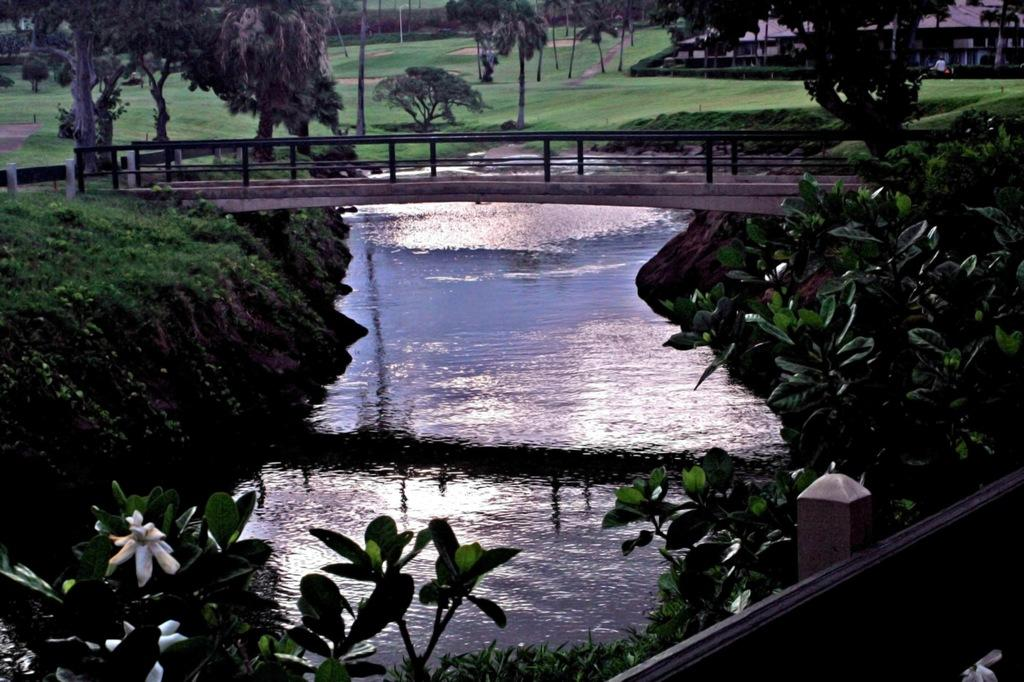What is the primary element visible in the image? There is water in the image. What structure is present over the water? There is a bridge with railings in the image. What type of vegetation can be seen on the ground? There is grass on the ground in the image. What other natural elements are present in the image? There are trees in the image. What can be seen in the background of the image? There is a building in the background of the image. What type of pencil can be seen floating on the water in the image? There is no pencil present in the image; it only features water, a bridge, grass, trees, and a building in the background. 